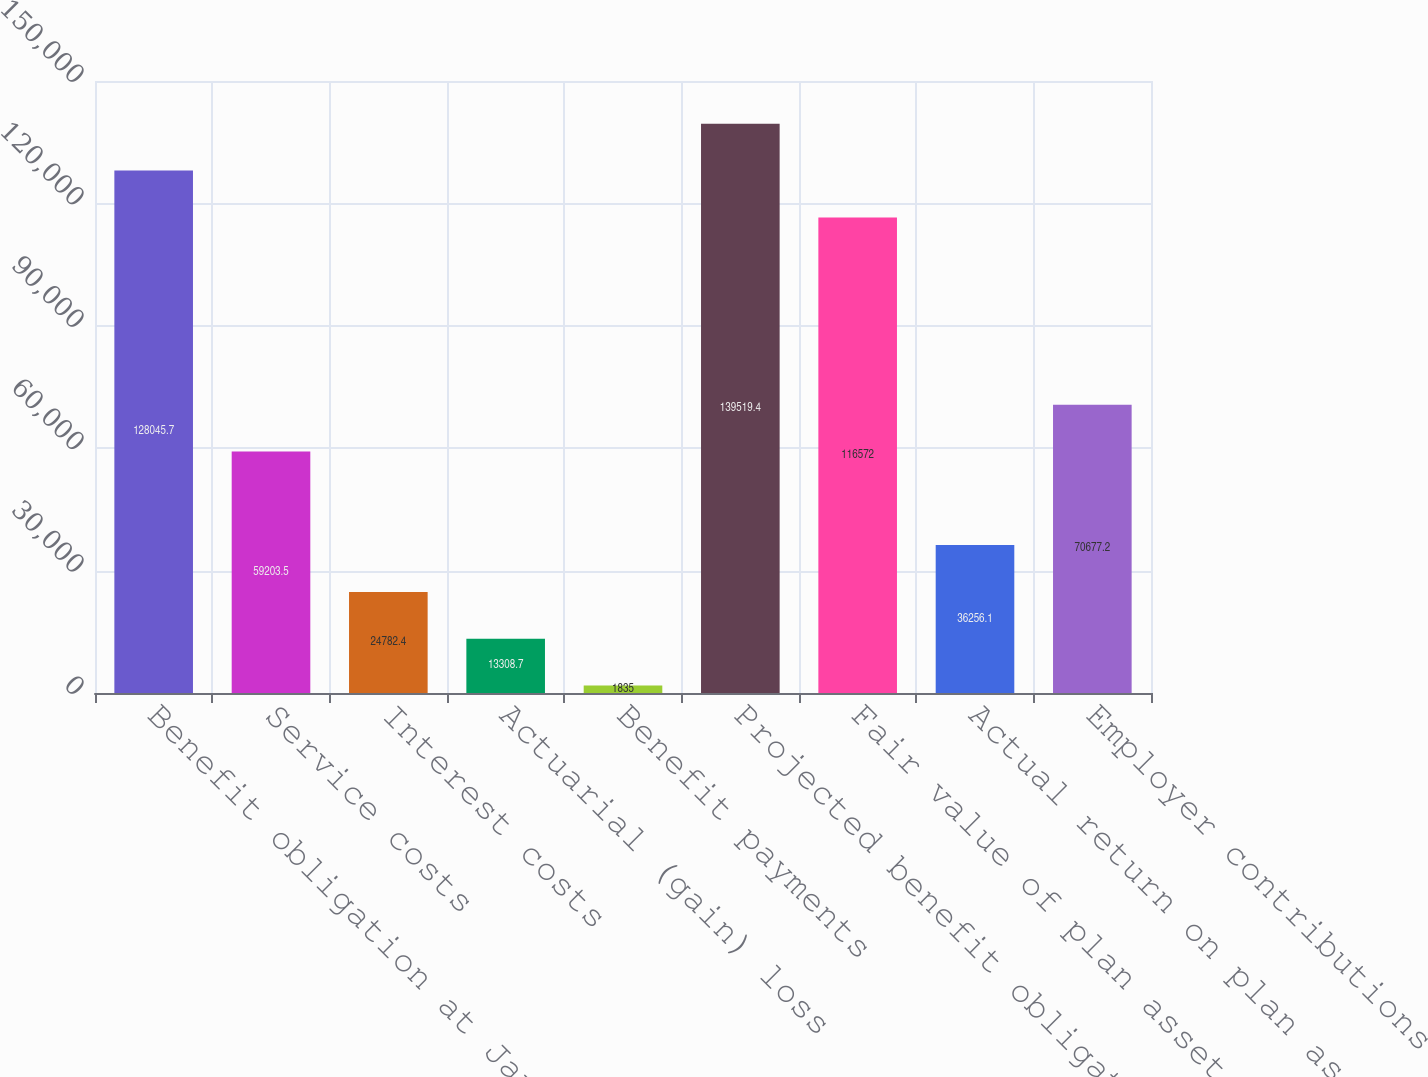Convert chart to OTSL. <chart><loc_0><loc_0><loc_500><loc_500><bar_chart><fcel>Benefit obligation at January<fcel>Service costs<fcel>Interest costs<fcel>Actuarial (gain) loss<fcel>Benefit payments<fcel>Projected benefit obligation<fcel>Fair value of plan assets at<fcel>Actual return on plan assets<fcel>Employer contributions<nl><fcel>128046<fcel>59203.5<fcel>24782.4<fcel>13308.7<fcel>1835<fcel>139519<fcel>116572<fcel>36256.1<fcel>70677.2<nl></chart> 